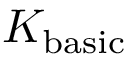Convert formula to latex. <formula><loc_0><loc_0><loc_500><loc_500>K _ { b a s i c }</formula> 